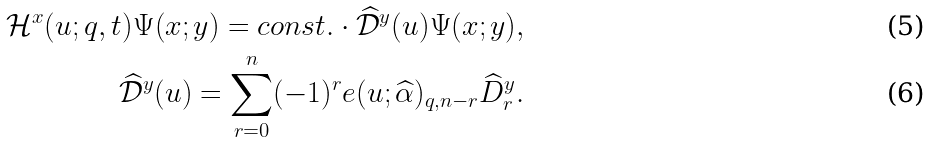<formula> <loc_0><loc_0><loc_500><loc_500>\mathcal { H } ^ { x } ( u ; q , t ) \Psi ( x ; y ) = c o n s t . \cdot \widehat { \mathcal { D } } ^ { y } ( u ) \Psi ( x ; y ) , \\ \widehat { \mathcal { D } } ^ { y } ( u ) = \sum _ { r = 0 } ^ { n } ( - 1 ) ^ { r } e ( u ; \widehat { \alpha } ) _ { q , n - r } \widehat { D } _ { r } ^ { y } .</formula> 